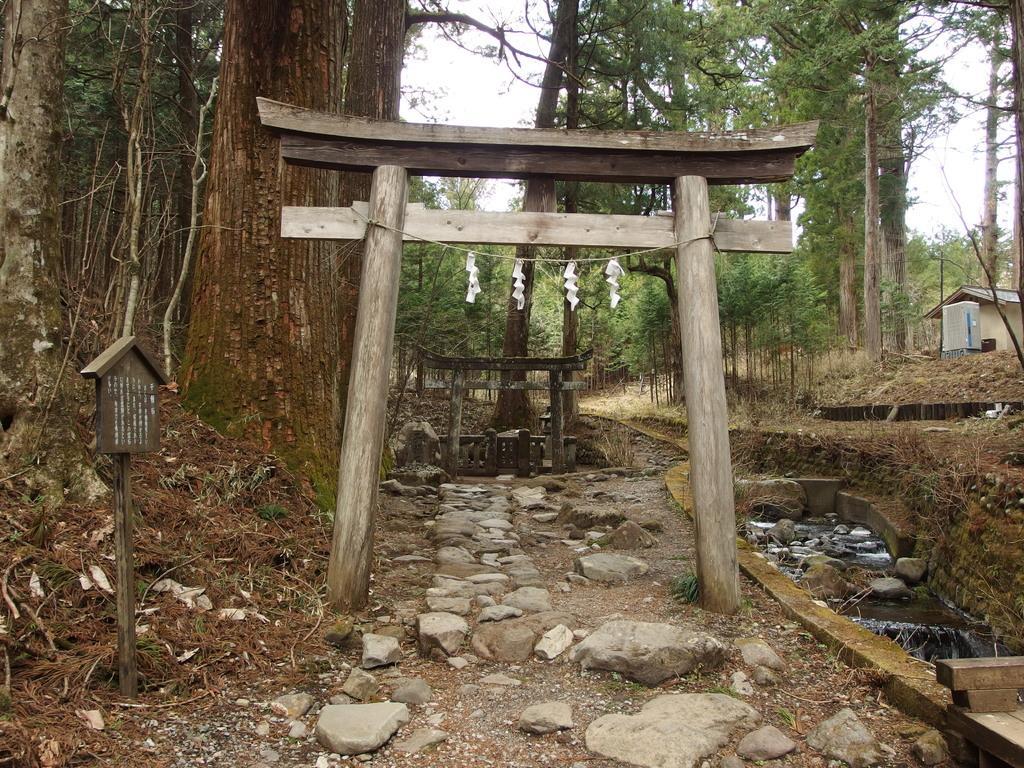Can you describe this image briefly? In this image, at the middle there is a wooden gate, at the left side there are some trees, at the right side there is a small canal and there is water, at the background there are some green color trees and there is a sky. 